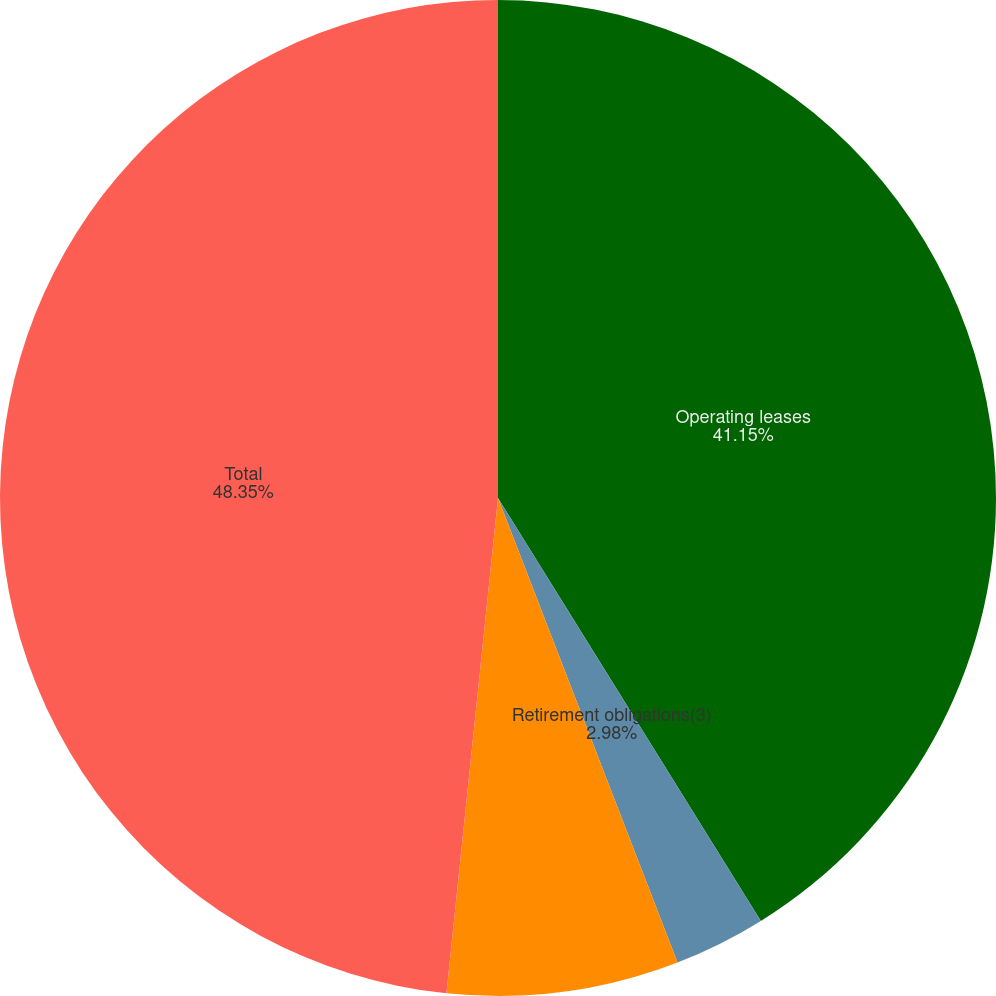<chart> <loc_0><loc_0><loc_500><loc_500><pie_chart><fcel>Operating leases<fcel>Retirement obligations(3)<fcel>Other commitments(4)<fcel>Total<nl><fcel>41.15%<fcel>2.98%<fcel>7.52%<fcel>48.35%<nl></chart> 